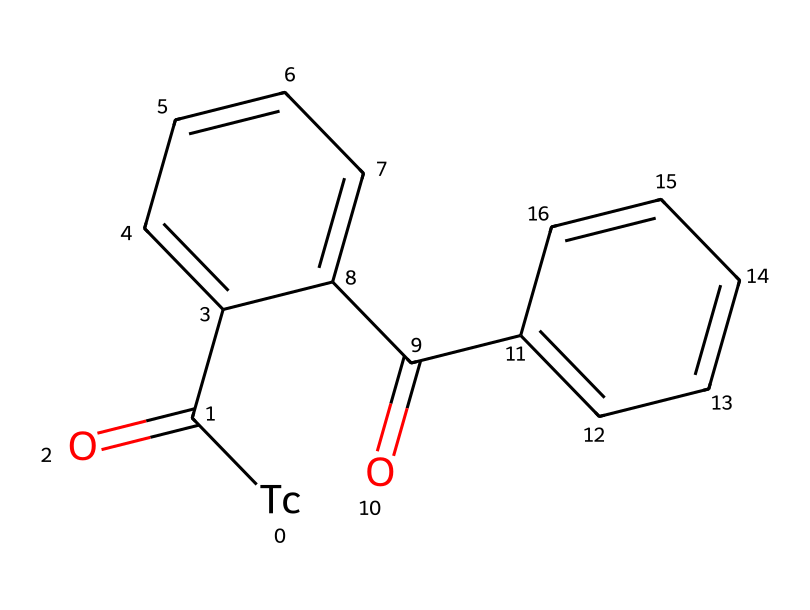What is the central metal atom in this chemical structure? The central metal atom is indicated by the symbol [Tc] in the SMILES, representing technetium.
Answer: technetium How many carbon atoms are present in the structure? By analyzing the SMILES, there are 12 carbon atoms as counted from the connected "C" representations in the structure.
Answer: 12 What type of chemical is this structure primarily classified as? This chemical is classified as an organometallic compound due to the presence of carbon (C) atoms bonded to a metal (technetium, Tc).
Answer: organometallic What functional groups can be identified in this chemical structure? The structure contains two ketone functional groups, indicated by the C(=O) parts in the SMILES.
Answer: ketone What is the oxidation state of technetium in this compound? The oxidation state of technetium is typically +7 in organometallic complexes, which corresponds with its bonding situation in the SMILES structure.
Answer: +7 How many rings are present in the structure? There are two aromatic rings present, identified by the sequences of "C1=CC=CC=C" and "C2=CC=CC=C" in the SMILES notation.
Answer: 2 